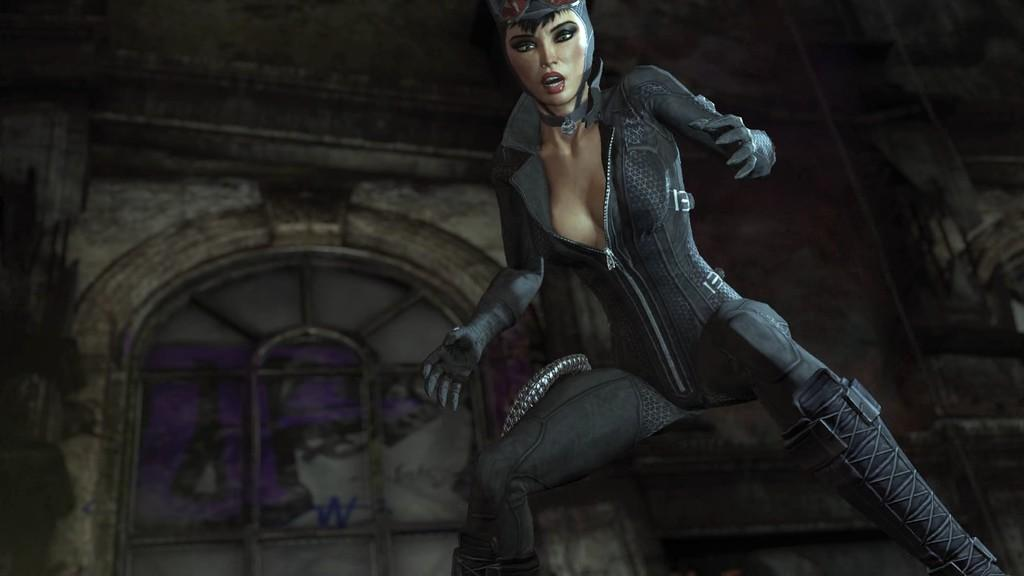What type of image is being described? The image is animated. Can you describe the woman in the image? There is a woman standing in the image. What can be seen through the window in the image? Unfortunately, the facts provided do not give any information about what can be seen through the window. What is the background of the image made of? There is a wall visible in the image, which suggests that the background is made of a solid material. What type of flower is the woman holding in the image? There is no flower present in the image, as the facts provided do not mention any flowers. 